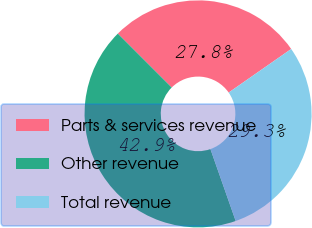<chart> <loc_0><loc_0><loc_500><loc_500><pie_chart><fcel>Parts & services revenue<fcel>Other revenue<fcel>Total revenue<nl><fcel>27.81%<fcel>42.88%<fcel>29.31%<nl></chart> 